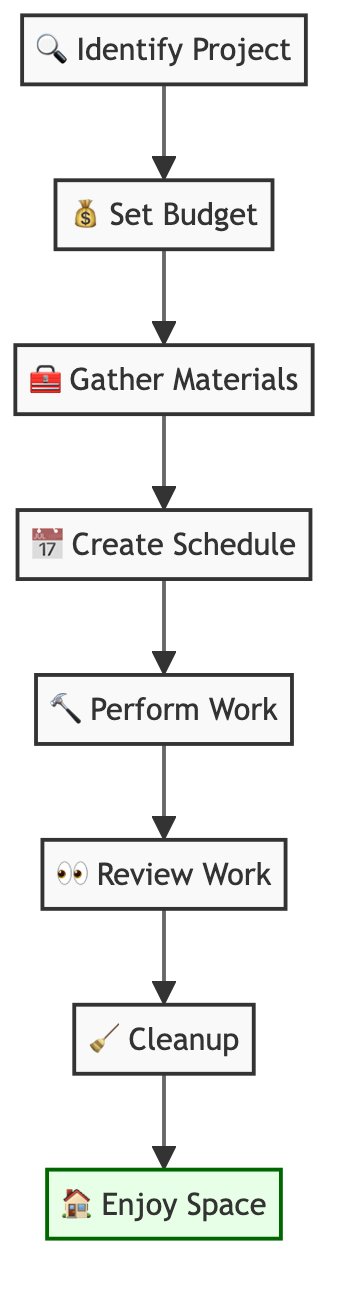What is the first task in the flow chart? The first task is indicated by the initial node in the flow chart, which is "Identify the Home Improvement Project."
Answer: Identify the Home Improvement Project How many total tasks are in the flow chart? By counting the individual tasks listed in the flow chart, there are a total of eight tasks.
Answer: 8 What is the task that follows "Set a Budget"? According to the flow direction in the diagram, "Gather Materials and Tools" follows directly after "Set a Budget."
Answer: Gather Materials and Tools What task is performed after "Review the Work"? The task that is performed after "Review the Work" is "Cleanup," as indicated by the arrows connecting the nodes in the flow chart.
Answer: Cleanup What task is the last step in the process? The last step in the process is indicated by the final node in the flow chart, which is "Enjoy the Improved Space."
Answer: Enjoy the Improved Space How many steps are there before performing the work? There are four steps before reaching the "Perform the Work" task: "Identify the Home Improvement Project," "Set a Budget," "Gather Materials and Tools," and "Create a Work Schedule."
Answer: 4 What type of task is indicated by the icon of a paint brush in the chart? The icon used in the flow chart for "Perform the Work" symbolizes the actual execution of the home improvement tasks.
Answer: Perform the Work Which task involves checking the quality of the work done? The task dedicated to evaluating the quality of the work is "Review the Work," as it specifically focuses on inspecting the completed tasks.
Answer: Review the Work What are the first two tasks in the flow chart? The first two tasks outlined in the flow chart are "Identify the Home Improvement Project" and "Set a Budget," which are sequentially arranged.
Answer: Identify the Home Improvement Project, Set a Budget 